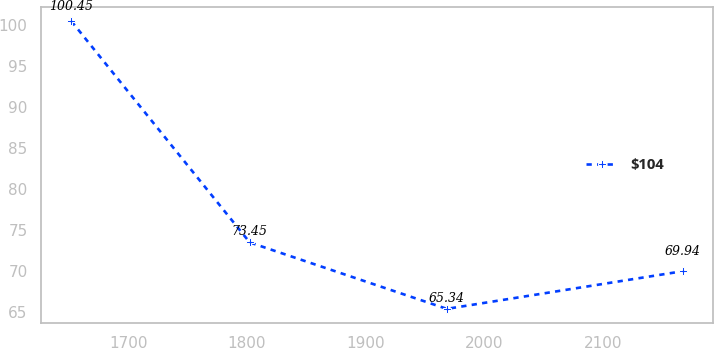Convert chart to OTSL. <chart><loc_0><loc_0><loc_500><loc_500><line_chart><ecel><fcel>$104<nl><fcel>1652.34<fcel>100.45<nl><fcel>1802.38<fcel>73.45<nl><fcel>1968.2<fcel>65.34<nl><fcel>2166.76<fcel>69.94<nl></chart> 